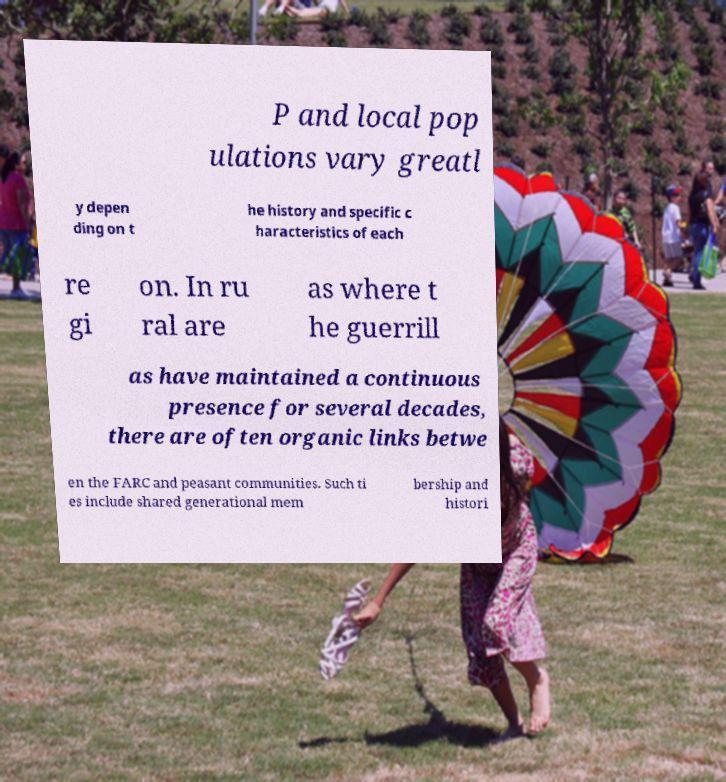For documentation purposes, I need the text within this image transcribed. Could you provide that? P and local pop ulations vary greatl y depen ding on t he history and specific c haracteristics of each re gi on. In ru ral are as where t he guerrill as have maintained a continuous presence for several decades, there are often organic links betwe en the FARC and peasant communities. Such ti es include shared generational mem bership and histori 